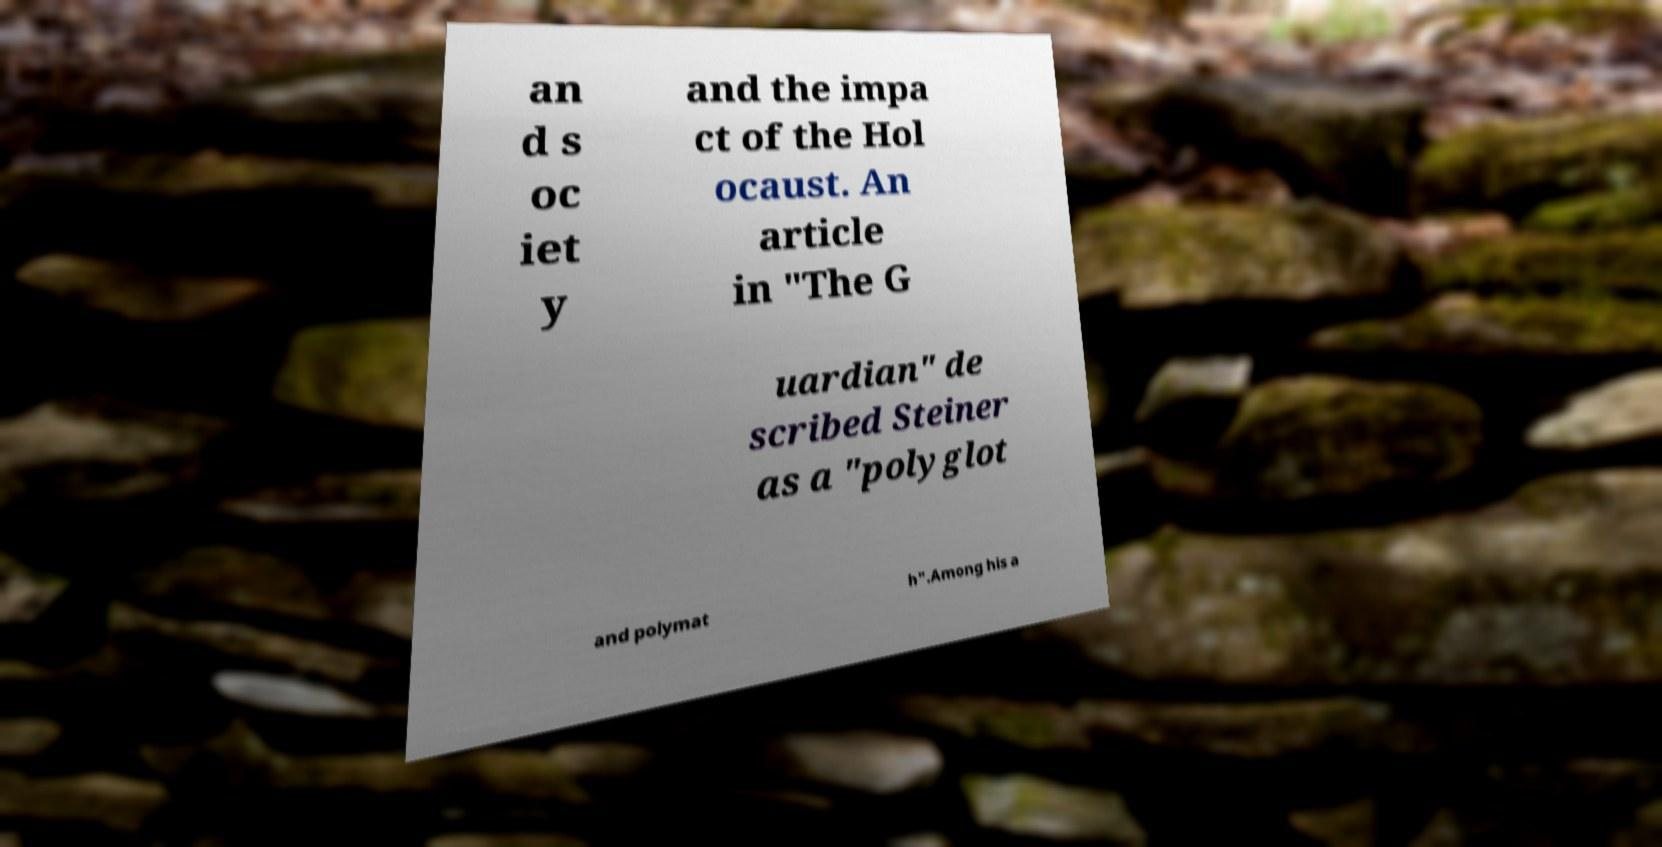For documentation purposes, I need the text within this image transcribed. Could you provide that? an d s oc iet y and the impa ct of the Hol ocaust. An article in "The G uardian" de scribed Steiner as a "polyglot and polymat h".Among his a 